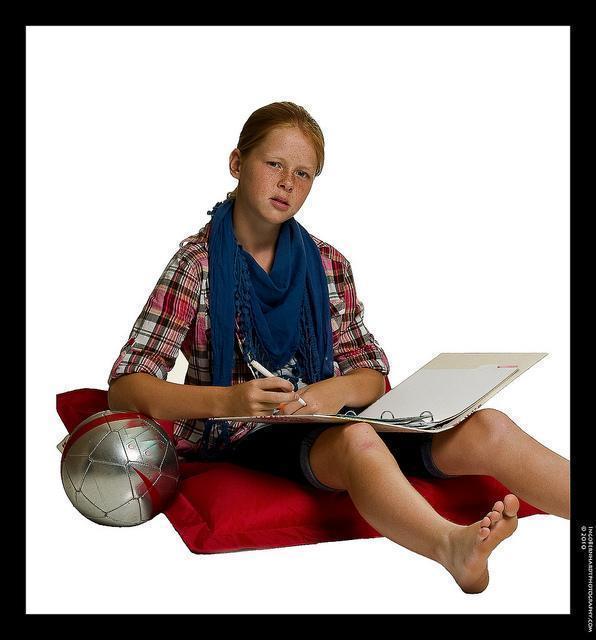What happened to the background?
Make your selection from the four choices given to correctly answer the question.
Options: Edited out, slightly overexposed, blurred, left unchanged. Edited out. 